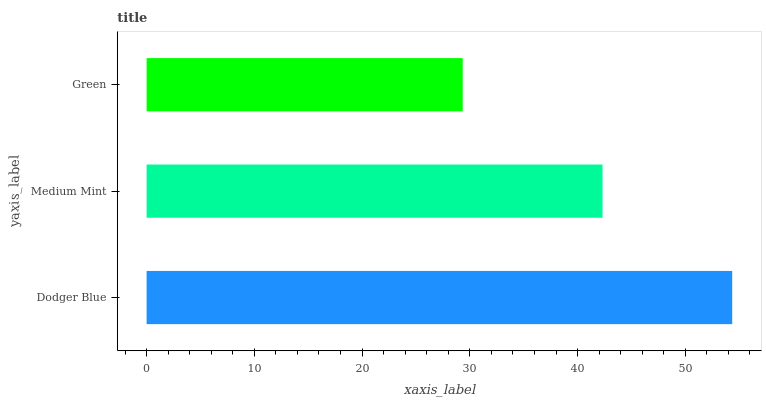Is Green the minimum?
Answer yes or no. Yes. Is Dodger Blue the maximum?
Answer yes or no. Yes. Is Medium Mint the minimum?
Answer yes or no. No. Is Medium Mint the maximum?
Answer yes or no. No. Is Dodger Blue greater than Medium Mint?
Answer yes or no. Yes. Is Medium Mint less than Dodger Blue?
Answer yes or no. Yes. Is Medium Mint greater than Dodger Blue?
Answer yes or no. No. Is Dodger Blue less than Medium Mint?
Answer yes or no. No. Is Medium Mint the high median?
Answer yes or no. Yes. Is Medium Mint the low median?
Answer yes or no. Yes. Is Dodger Blue the high median?
Answer yes or no. No. Is Green the low median?
Answer yes or no. No. 